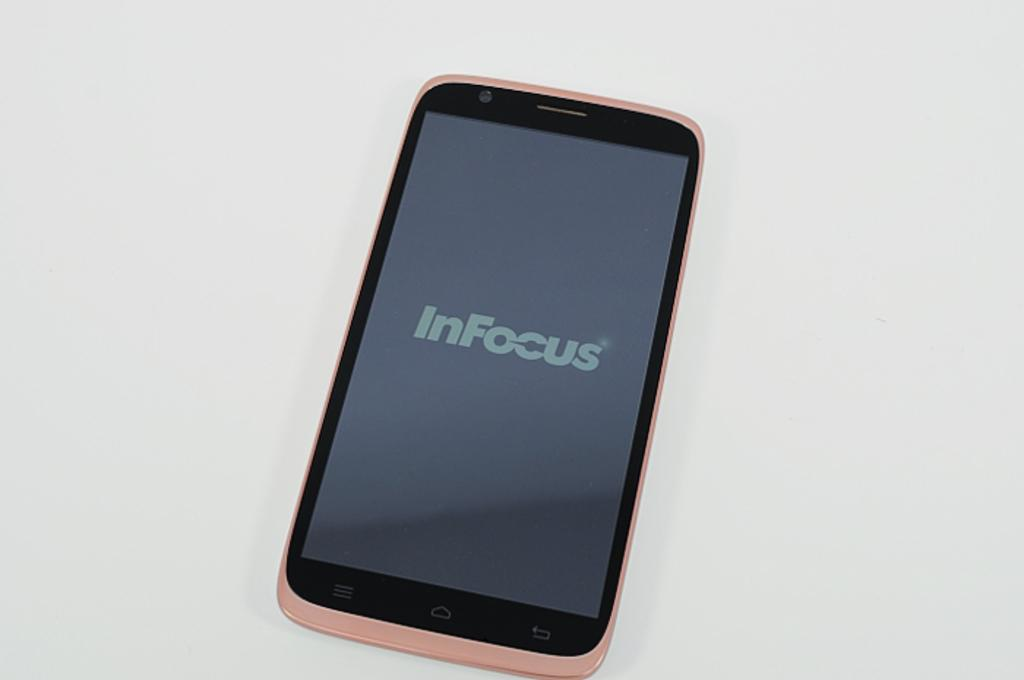<image>
Relay a brief, clear account of the picture shown. a pink cellphone with the words In Focus on the screen 